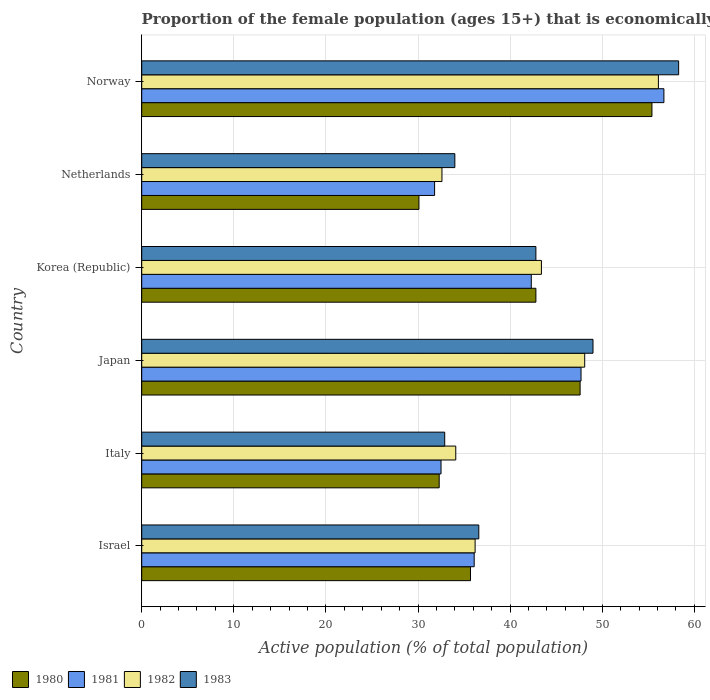Are the number of bars on each tick of the Y-axis equal?
Provide a succinct answer. Yes. How many bars are there on the 2nd tick from the top?
Keep it short and to the point. 4. What is the label of the 4th group of bars from the top?
Make the answer very short. Japan. In how many cases, is the number of bars for a given country not equal to the number of legend labels?
Offer a terse response. 0. What is the proportion of the female population that is economically active in 1983 in Norway?
Your answer should be very brief. 58.3. Across all countries, what is the maximum proportion of the female population that is economically active in 1982?
Make the answer very short. 56.1. Across all countries, what is the minimum proportion of the female population that is economically active in 1981?
Provide a short and direct response. 31.8. What is the total proportion of the female population that is economically active in 1982 in the graph?
Offer a very short reply. 250.5. What is the difference between the proportion of the female population that is economically active in 1981 in Israel and that in Norway?
Offer a terse response. -20.6. What is the difference between the proportion of the female population that is economically active in 1982 in Italy and the proportion of the female population that is economically active in 1983 in Korea (Republic)?
Offer a terse response. -8.7. What is the average proportion of the female population that is economically active in 1982 per country?
Provide a succinct answer. 41.75. What is the difference between the proportion of the female population that is economically active in 1983 and proportion of the female population that is economically active in 1982 in Norway?
Offer a very short reply. 2.2. What is the ratio of the proportion of the female population that is economically active in 1983 in Israel to that in Italy?
Provide a succinct answer. 1.11. Is the difference between the proportion of the female population that is economically active in 1983 in Italy and Korea (Republic) greater than the difference between the proportion of the female population that is economically active in 1982 in Italy and Korea (Republic)?
Offer a very short reply. No. What is the difference between the highest and the second highest proportion of the female population that is economically active in 1981?
Your answer should be compact. 9. What is the difference between the highest and the lowest proportion of the female population that is economically active in 1981?
Provide a succinct answer. 24.9. In how many countries, is the proportion of the female population that is economically active in 1980 greater than the average proportion of the female population that is economically active in 1980 taken over all countries?
Offer a terse response. 3. Is it the case that in every country, the sum of the proportion of the female population that is economically active in 1980 and proportion of the female population that is economically active in 1983 is greater than the sum of proportion of the female population that is economically active in 1982 and proportion of the female population that is economically active in 1981?
Provide a short and direct response. No. What does the 2nd bar from the top in Israel represents?
Make the answer very short. 1982. Does the graph contain any zero values?
Offer a terse response. No. Where does the legend appear in the graph?
Offer a terse response. Bottom left. How many legend labels are there?
Make the answer very short. 4. What is the title of the graph?
Your answer should be very brief. Proportion of the female population (ages 15+) that is economically active. What is the label or title of the X-axis?
Provide a short and direct response. Active population (% of total population). What is the Active population (% of total population) in 1980 in Israel?
Your answer should be compact. 35.7. What is the Active population (% of total population) of 1981 in Israel?
Provide a short and direct response. 36.1. What is the Active population (% of total population) in 1982 in Israel?
Give a very brief answer. 36.2. What is the Active population (% of total population) in 1983 in Israel?
Offer a terse response. 36.6. What is the Active population (% of total population) of 1980 in Italy?
Offer a terse response. 32.3. What is the Active population (% of total population) in 1981 in Italy?
Provide a short and direct response. 32.5. What is the Active population (% of total population) of 1982 in Italy?
Provide a succinct answer. 34.1. What is the Active population (% of total population) of 1983 in Italy?
Your response must be concise. 32.9. What is the Active population (% of total population) of 1980 in Japan?
Provide a short and direct response. 47.6. What is the Active population (% of total population) of 1981 in Japan?
Your answer should be compact. 47.7. What is the Active population (% of total population) in 1982 in Japan?
Make the answer very short. 48.1. What is the Active population (% of total population) of 1983 in Japan?
Ensure brevity in your answer.  49. What is the Active population (% of total population) of 1980 in Korea (Republic)?
Provide a short and direct response. 42.8. What is the Active population (% of total population) in 1981 in Korea (Republic)?
Provide a short and direct response. 42.3. What is the Active population (% of total population) in 1982 in Korea (Republic)?
Your response must be concise. 43.4. What is the Active population (% of total population) in 1983 in Korea (Republic)?
Offer a terse response. 42.8. What is the Active population (% of total population) of 1980 in Netherlands?
Offer a very short reply. 30.1. What is the Active population (% of total population) of 1981 in Netherlands?
Your answer should be very brief. 31.8. What is the Active population (% of total population) in 1982 in Netherlands?
Your answer should be compact. 32.6. What is the Active population (% of total population) in 1980 in Norway?
Offer a very short reply. 55.4. What is the Active population (% of total population) in 1981 in Norway?
Keep it short and to the point. 56.7. What is the Active population (% of total population) of 1982 in Norway?
Your answer should be very brief. 56.1. What is the Active population (% of total population) of 1983 in Norway?
Ensure brevity in your answer.  58.3. Across all countries, what is the maximum Active population (% of total population) of 1980?
Your response must be concise. 55.4. Across all countries, what is the maximum Active population (% of total population) of 1981?
Offer a very short reply. 56.7. Across all countries, what is the maximum Active population (% of total population) in 1982?
Your answer should be very brief. 56.1. Across all countries, what is the maximum Active population (% of total population) in 1983?
Give a very brief answer. 58.3. Across all countries, what is the minimum Active population (% of total population) in 1980?
Provide a short and direct response. 30.1. Across all countries, what is the minimum Active population (% of total population) of 1981?
Provide a short and direct response. 31.8. Across all countries, what is the minimum Active population (% of total population) of 1982?
Offer a terse response. 32.6. Across all countries, what is the minimum Active population (% of total population) in 1983?
Keep it short and to the point. 32.9. What is the total Active population (% of total population) in 1980 in the graph?
Offer a very short reply. 243.9. What is the total Active population (% of total population) of 1981 in the graph?
Offer a terse response. 247.1. What is the total Active population (% of total population) in 1982 in the graph?
Give a very brief answer. 250.5. What is the total Active population (% of total population) of 1983 in the graph?
Offer a terse response. 253.6. What is the difference between the Active population (% of total population) in 1980 in Israel and that in Italy?
Provide a succinct answer. 3.4. What is the difference between the Active population (% of total population) of 1981 in Israel and that in Italy?
Give a very brief answer. 3.6. What is the difference between the Active population (% of total population) of 1982 in Israel and that in Italy?
Provide a short and direct response. 2.1. What is the difference between the Active population (% of total population) in 1983 in Israel and that in Japan?
Offer a very short reply. -12.4. What is the difference between the Active population (% of total population) in 1981 in Israel and that in Korea (Republic)?
Provide a succinct answer. -6.2. What is the difference between the Active population (% of total population) of 1982 in Israel and that in Korea (Republic)?
Offer a very short reply. -7.2. What is the difference between the Active population (% of total population) in 1980 in Israel and that in Netherlands?
Offer a terse response. 5.6. What is the difference between the Active population (% of total population) of 1982 in Israel and that in Netherlands?
Provide a short and direct response. 3.6. What is the difference between the Active population (% of total population) in 1980 in Israel and that in Norway?
Your answer should be compact. -19.7. What is the difference between the Active population (% of total population) in 1981 in Israel and that in Norway?
Your answer should be compact. -20.6. What is the difference between the Active population (% of total population) in 1982 in Israel and that in Norway?
Your answer should be very brief. -19.9. What is the difference between the Active population (% of total population) in 1983 in Israel and that in Norway?
Your answer should be very brief. -21.7. What is the difference between the Active population (% of total population) of 1980 in Italy and that in Japan?
Provide a short and direct response. -15.3. What is the difference between the Active population (% of total population) of 1981 in Italy and that in Japan?
Your answer should be compact. -15.2. What is the difference between the Active population (% of total population) in 1982 in Italy and that in Japan?
Provide a succinct answer. -14. What is the difference between the Active population (% of total population) in 1983 in Italy and that in Japan?
Offer a terse response. -16.1. What is the difference between the Active population (% of total population) of 1980 in Italy and that in Korea (Republic)?
Keep it short and to the point. -10.5. What is the difference between the Active population (% of total population) of 1982 in Italy and that in Korea (Republic)?
Make the answer very short. -9.3. What is the difference between the Active population (% of total population) of 1983 in Italy and that in Korea (Republic)?
Give a very brief answer. -9.9. What is the difference between the Active population (% of total population) in 1980 in Italy and that in Netherlands?
Your answer should be compact. 2.2. What is the difference between the Active population (% of total population) in 1983 in Italy and that in Netherlands?
Give a very brief answer. -1.1. What is the difference between the Active population (% of total population) of 1980 in Italy and that in Norway?
Your response must be concise. -23.1. What is the difference between the Active population (% of total population) of 1981 in Italy and that in Norway?
Provide a succinct answer. -24.2. What is the difference between the Active population (% of total population) of 1982 in Italy and that in Norway?
Offer a very short reply. -22. What is the difference between the Active population (% of total population) of 1983 in Italy and that in Norway?
Offer a terse response. -25.4. What is the difference between the Active population (% of total population) in 1980 in Japan and that in Netherlands?
Offer a terse response. 17.5. What is the difference between the Active population (% of total population) in 1982 in Japan and that in Netherlands?
Give a very brief answer. 15.5. What is the difference between the Active population (% of total population) of 1981 in Japan and that in Norway?
Provide a succinct answer. -9. What is the difference between the Active population (% of total population) in 1980 in Korea (Republic) and that in Norway?
Your answer should be compact. -12.6. What is the difference between the Active population (% of total population) in 1981 in Korea (Republic) and that in Norway?
Offer a very short reply. -14.4. What is the difference between the Active population (% of total population) in 1982 in Korea (Republic) and that in Norway?
Your answer should be compact. -12.7. What is the difference between the Active population (% of total population) of 1983 in Korea (Republic) and that in Norway?
Your answer should be compact. -15.5. What is the difference between the Active population (% of total population) in 1980 in Netherlands and that in Norway?
Make the answer very short. -25.3. What is the difference between the Active population (% of total population) of 1981 in Netherlands and that in Norway?
Offer a very short reply. -24.9. What is the difference between the Active population (% of total population) of 1982 in Netherlands and that in Norway?
Offer a terse response. -23.5. What is the difference between the Active population (% of total population) in 1983 in Netherlands and that in Norway?
Offer a very short reply. -24.3. What is the difference between the Active population (% of total population) of 1980 in Israel and the Active population (% of total population) of 1981 in Italy?
Provide a succinct answer. 3.2. What is the difference between the Active population (% of total population) in 1980 in Israel and the Active population (% of total population) in 1982 in Italy?
Provide a succinct answer. 1.6. What is the difference between the Active population (% of total population) of 1982 in Israel and the Active population (% of total population) of 1983 in Italy?
Make the answer very short. 3.3. What is the difference between the Active population (% of total population) of 1980 in Israel and the Active population (% of total population) of 1982 in Japan?
Your answer should be very brief. -12.4. What is the difference between the Active population (% of total population) in 1980 in Israel and the Active population (% of total population) in 1983 in Japan?
Provide a succinct answer. -13.3. What is the difference between the Active population (% of total population) of 1981 in Israel and the Active population (% of total population) of 1983 in Japan?
Give a very brief answer. -12.9. What is the difference between the Active population (% of total population) in 1982 in Israel and the Active population (% of total population) in 1983 in Japan?
Make the answer very short. -12.8. What is the difference between the Active population (% of total population) in 1980 in Israel and the Active population (% of total population) in 1983 in Korea (Republic)?
Your answer should be very brief. -7.1. What is the difference between the Active population (% of total population) in 1980 in Israel and the Active population (% of total population) in 1981 in Netherlands?
Your answer should be compact. 3.9. What is the difference between the Active population (% of total population) in 1980 in Israel and the Active population (% of total population) in 1983 in Netherlands?
Your answer should be very brief. 1.7. What is the difference between the Active population (% of total population) of 1981 in Israel and the Active population (% of total population) of 1982 in Netherlands?
Offer a terse response. 3.5. What is the difference between the Active population (% of total population) in 1982 in Israel and the Active population (% of total population) in 1983 in Netherlands?
Your answer should be compact. 2.2. What is the difference between the Active population (% of total population) of 1980 in Israel and the Active population (% of total population) of 1982 in Norway?
Keep it short and to the point. -20.4. What is the difference between the Active population (% of total population) in 1980 in Israel and the Active population (% of total population) in 1983 in Norway?
Your answer should be compact. -22.6. What is the difference between the Active population (% of total population) in 1981 in Israel and the Active population (% of total population) in 1982 in Norway?
Your answer should be compact. -20. What is the difference between the Active population (% of total population) in 1981 in Israel and the Active population (% of total population) in 1983 in Norway?
Keep it short and to the point. -22.2. What is the difference between the Active population (% of total population) in 1982 in Israel and the Active population (% of total population) in 1983 in Norway?
Make the answer very short. -22.1. What is the difference between the Active population (% of total population) of 1980 in Italy and the Active population (% of total population) of 1981 in Japan?
Offer a terse response. -15.4. What is the difference between the Active population (% of total population) of 1980 in Italy and the Active population (% of total population) of 1982 in Japan?
Ensure brevity in your answer.  -15.8. What is the difference between the Active population (% of total population) in 1980 in Italy and the Active population (% of total population) in 1983 in Japan?
Your response must be concise. -16.7. What is the difference between the Active population (% of total population) in 1981 in Italy and the Active population (% of total population) in 1982 in Japan?
Offer a terse response. -15.6. What is the difference between the Active population (% of total population) of 1981 in Italy and the Active population (% of total population) of 1983 in Japan?
Keep it short and to the point. -16.5. What is the difference between the Active population (% of total population) of 1982 in Italy and the Active population (% of total population) of 1983 in Japan?
Offer a very short reply. -14.9. What is the difference between the Active population (% of total population) in 1980 in Italy and the Active population (% of total population) in 1982 in Korea (Republic)?
Your answer should be compact. -11.1. What is the difference between the Active population (% of total population) in 1980 in Italy and the Active population (% of total population) in 1983 in Korea (Republic)?
Offer a very short reply. -10.5. What is the difference between the Active population (% of total population) in 1982 in Italy and the Active population (% of total population) in 1983 in Korea (Republic)?
Provide a succinct answer. -8.7. What is the difference between the Active population (% of total population) in 1980 in Italy and the Active population (% of total population) in 1983 in Netherlands?
Provide a short and direct response. -1.7. What is the difference between the Active population (% of total population) in 1981 in Italy and the Active population (% of total population) in 1983 in Netherlands?
Your response must be concise. -1.5. What is the difference between the Active population (% of total population) of 1980 in Italy and the Active population (% of total population) of 1981 in Norway?
Make the answer very short. -24.4. What is the difference between the Active population (% of total population) in 1980 in Italy and the Active population (% of total population) in 1982 in Norway?
Make the answer very short. -23.8. What is the difference between the Active population (% of total population) of 1981 in Italy and the Active population (% of total population) of 1982 in Norway?
Your response must be concise. -23.6. What is the difference between the Active population (% of total population) in 1981 in Italy and the Active population (% of total population) in 1983 in Norway?
Offer a terse response. -25.8. What is the difference between the Active population (% of total population) of 1982 in Italy and the Active population (% of total population) of 1983 in Norway?
Give a very brief answer. -24.2. What is the difference between the Active population (% of total population) of 1980 in Japan and the Active population (% of total population) of 1982 in Korea (Republic)?
Provide a short and direct response. 4.2. What is the difference between the Active population (% of total population) of 1980 in Japan and the Active population (% of total population) of 1983 in Korea (Republic)?
Offer a terse response. 4.8. What is the difference between the Active population (% of total population) in 1981 in Japan and the Active population (% of total population) in 1983 in Korea (Republic)?
Your response must be concise. 4.9. What is the difference between the Active population (% of total population) in 1982 in Japan and the Active population (% of total population) in 1983 in Korea (Republic)?
Your answer should be compact. 5.3. What is the difference between the Active population (% of total population) of 1980 in Japan and the Active population (% of total population) of 1982 in Netherlands?
Your answer should be compact. 15. What is the difference between the Active population (% of total population) in 1981 in Japan and the Active population (% of total population) in 1983 in Netherlands?
Your answer should be very brief. 13.7. What is the difference between the Active population (% of total population) in 1982 in Japan and the Active population (% of total population) in 1983 in Netherlands?
Your answer should be very brief. 14.1. What is the difference between the Active population (% of total population) in 1980 in Japan and the Active population (% of total population) in 1982 in Norway?
Your answer should be very brief. -8.5. What is the difference between the Active population (% of total population) of 1980 in Japan and the Active population (% of total population) of 1983 in Norway?
Your response must be concise. -10.7. What is the difference between the Active population (% of total population) of 1981 in Japan and the Active population (% of total population) of 1983 in Norway?
Offer a terse response. -10.6. What is the difference between the Active population (% of total population) of 1982 in Japan and the Active population (% of total population) of 1983 in Norway?
Keep it short and to the point. -10.2. What is the difference between the Active population (% of total population) in 1980 in Korea (Republic) and the Active population (% of total population) in 1981 in Netherlands?
Provide a succinct answer. 11. What is the difference between the Active population (% of total population) in 1980 in Korea (Republic) and the Active population (% of total population) in 1983 in Netherlands?
Your response must be concise. 8.8. What is the difference between the Active population (% of total population) in 1981 in Korea (Republic) and the Active population (% of total population) in 1982 in Netherlands?
Provide a succinct answer. 9.7. What is the difference between the Active population (% of total population) of 1981 in Korea (Republic) and the Active population (% of total population) of 1983 in Netherlands?
Provide a succinct answer. 8.3. What is the difference between the Active population (% of total population) in 1982 in Korea (Republic) and the Active population (% of total population) in 1983 in Netherlands?
Give a very brief answer. 9.4. What is the difference between the Active population (% of total population) of 1980 in Korea (Republic) and the Active population (% of total population) of 1983 in Norway?
Ensure brevity in your answer.  -15.5. What is the difference between the Active population (% of total population) of 1981 in Korea (Republic) and the Active population (% of total population) of 1983 in Norway?
Provide a short and direct response. -16. What is the difference between the Active population (% of total population) in 1982 in Korea (Republic) and the Active population (% of total population) in 1983 in Norway?
Ensure brevity in your answer.  -14.9. What is the difference between the Active population (% of total population) in 1980 in Netherlands and the Active population (% of total population) in 1981 in Norway?
Provide a short and direct response. -26.6. What is the difference between the Active population (% of total population) in 1980 in Netherlands and the Active population (% of total population) in 1983 in Norway?
Give a very brief answer. -28.2. What is the difference between the Active population (% of total population) of 1981 in Netherlands and the Active population (% of total population) of 1982 in Norway?
Keep it short and to the point. -24.3. What is the difference between the Active population (% of total population) of 1981 in Netherlands and the Active population (% of total population) of 1983 in Norway?
Your response must be concise. -26.5. What is the difference between the Active population (% of total population) in 1982 in Netherlands and the Active population (% of total population) in 1983 in Norway?
Ensure brevity in your answer.  -25.7. What is the average Active population (% of total population) in 1980 per country?
Offer a very short reply. 40.65. What is the average Active population (% of total population) in 1981 per country?
Ensure brevity in your answer.  41.18. What is the average Active population (% of total population) in 1982 per country?
Your answer should be compact. 41.75. What is the average Active population (% of total population) in 1983 per country?
Offer a very short reply. 42.27. What is the difference between the Active population (% of total population) of 1980 and Active population (% of total population) of 1981 in Israel?
Provide a succinct answer. -0.4. What is the difference between the Active population (% of total population) of 1980 and Active population (% of total population) of 1983 in Israel?
Keep it short and to the point. -0.9. What is the difference between the Active population (% of total population) in 1981 and Active population (% of total population) in 1982 in Israel?
Provide a succinct answer. -0.1. What is the difference between the Active population (% of total population) of 1981 and Active population (% of total population) of 1983 in Israel?
Offer a very short reply. -0.5. What is the difference between the Active population (% of total population) in 1982 and Active population (% of total population) in 1983 in Israel?
Make the answer very short. -0.4. What is the difference between the Active population (% of total population) in 1980 and Active population (% of total population) in 1982 in Italy?
Make the answer very short. -1.8. What is the difference between the Active population (% of total population) in 1981 and Active population (% of total population) in 1983 in Italy?
Offer a very short reply. -0.4. What is the difference between the Active population (% of total population) of 1980 and Active population (% of total population) of 1981 in Japan?
Offer a very short reply. -0.1. What is the difference between the Active population (% of total population) of 1981 and Active population (% of total population) of 1982 in Japan?
Ensure brevity in your answer.  -0.4. What is the difference between the Active population (% of total population) in 1980 and Active population (% of total population) in 1981 in Korea (Republic)?
Your answer should be very brief. 0.5. What is the difference between the Active population (% of total population) of 1981 and Active population (% of total population) of 1983 in Korea (Republic)?
Give a very brief answer. -0.5. What is the difference between the Active population (% of total population) of 1982 and Active population (% of total population) of 1983 in Korea (Republic)?
Provide a succinct answer. 0.6. What is the difference between the Active population (% of total population) of 1980 and Active population (% of total population) of 1982 in Netherlands?
Ensure brevity in your answer.  -2.5. What is the difference between the Active population (% of total population) of 1980 and Active population (% of total population) of 1983 in Netherlands?
Provide a succinct answer. -3.9. What is the difference between the Active population (% of total population) of 1981 and Active population (% of total population) of 1982 in Netherlands?
Your answer should be compact. -0.8. What is the difference between the Active population (% of total population) of 1981 and Active population (% of total population) of 1983 in Netherlands?
Your answer should be very brief. -2.2. What is the difference between the Active population (% of total population) in 1982 and Active population (% of total population) in 1983 in Netherlands?
Offer a very short reply. -1.4. What is the difference between the Active population (% of total population) in 1980 and Active population (% of total population) in 1981 in Norway?
Give a very brief answer. -1.3. What is the difference between the Active population (% of total population) of 1980 and Active population (% of total population) of 1983 in Norway?
Provide a short and direct response. -2.9. What is the difference between the Active population (% of total population) in 1981 and Active population (% of total population) in 1983 in Norway?
Provide a succinct answer. -1.6. What is the ratio of the Active population (% of total population) in 1980 in Israel to that in Italy?
Your answer should be very brief. 1.11. What is the ratio of the Active population (% of total population) in 1981 in Israel to that in Italy?
Offer a very short reply. 1.11. What is the ratio of the Active population (% of total population) of 1982 in Israel to that in Italy?
Make the answer very short. 1.06. What is the ratio of the Active population (% of total population) in 1983 in Israel to that in Italy?
Your answer should be compact. 1.11. What is the ratio of the Active population (% of total population) in 1981 in Israel to that in Japan?
Keep it short and to the point. 0.76. What is the ratio of the Active population (% of total population) in 1982 in Israel to that in Japan?
Provide a succinct answer. 0.75. What is the ratio of the Active population (% of total population) in 1983 in Israel to that in Japan?
Offer a terse response. 0.75. What is the ratio of the Active population (% of total population) of 1980 in Israel to that in Korea (Republic)?
Ensure brevity in your answer.  0.83. What is the ratio of the Active population (% of total population) in 1981 in Israel to that in Korea (Republic)?
Your answer should be compact. 0.85. What is the ratio of the Active population (% of total population) in 1982 in Israel to that in Korea (Republic)?
Offer a terse response. 0.83. What is the ratio of the Active population (% of total population) in 1983 in Israel to that in Korea (Republic)?
Ensure brevity in your answer.  0.86. What is the ratio of the Active population (% of total population) in 1980 in Israel to that in Netherlands?
Give a very brief answer. 1.19. What is the ratio of the Active population (% of total population) of 1981 in Israel to that in Netherlands?
Provide a short and direct response. 1.14. What is the ratio of the Active population (% of total population) in 1982 in Israel to that in Netherlands?
Ensure brevity in your answer.  1.11. What is the ratio of the Active population (% of total population) in 1983 in Israel to that in Netherlands?
Your answer should be compact. 1.08. What is the ratio of the Active population (% of total population) of 1980 in Israel to that in Norway?
Offer a very short reply. 0.64. What is the ratio of the Active population (% of total population) of 1981 in Israel to that in Norway?
Your answer should be compact. 0.64. What is the ratio of the Active population (% of total population) in 1982 in Israel to that in Norway?
Your answer should be compact. 0.65. What is the ratio of the Active population (% of total population) in 1983 in Israel to that in Norway?
Keep it short and to the point. 0.63. What is the ratio of the Active population (% of total population) in 1980 in Italy to that in Japan?
Your response must be concise. 0.68. What is the ratio of the Active population (% of total population) of 1981 in Italy to that in Japan?
Offer a terse response. 0.68. What is the ratio of the Active population (% of total population) of 1982 in Italy to that in Japan?
Provide a short and direct response. 0.71. What is the ratio of the Active population (% of total population) of 1983 in Italy to that in Japan?
Provide a succinct answer. 0.67. What is the ratio of the Active population (% of total population) of 1980 in Italy to that in Korea (Republic)?
Your answer should be compact. 0.75. What is the ratio of the Active population (% of total population) of 1981 in Italy to that in Korea (Republic)?
Your response must be concise. 0.77. What is the ratio of the Active population (% of total population) in 1982 in Italy to that in Korea (Republic)?
Provide a short and direct response. 0.79. What is the ratio of the Active population (% of total population) in 1983 in Italy to that in Korea (Republic)?
Make the answer very short. 0.77. What is the ratio of the Active population (% of total population) of 1980 in Italy to that in Netherlands?
Your answer should be compact. 1.07. What is the ratio of the Active population (% of total population) of 1982 in Italy to that in Netherlands?
Your answer should be very brief. 1.05. What is the ratio of the Active population (% of total population) in 1983 in Italy to that in Netherlands?
Your answer should be compact. 0.97. What is the ratio of the Active population (% of total population) of 1980 in Italy to that in Norway?
Your answer should be compact. 0.58. What is the ratio of the Active population (% of total population) of 1981 in Italy to that in Norway?
Your answer should be very brief. 0.57. What is the ratio of the Active population (% of total population) of 1982 in Italy to that in Norway?
Your answer should be compact. 0.61. What is the ratio of the Active population (% of total population) in 1983 in Italy to that in Norway?
Your answer should be very brief. 0.56. What is the ratio of the Active population (% of total population) in 1980 in Japan to that in Korea (Republic)?
Offer a very short reply. 1.11. What is the ratio of the Active population (% of total population) in 1981 in Japan to that in Korea (Republic)?
Make the answer very short. 1.13. What is the ratio of the Active population (% of total population) in 1982 in Japan to that in Korea (Republic)?
Offer a terse response. 1.11. What is the ratio of the Active population (% of total population) in 1983 in Japan to that in Korea (Republic)?
Provide a succinct answer. 1.14. What is the ratio of the Active population (% of total population) in 1980 in Japan to that in Netherlands?
Make the answer very short. 1.58. What is the ratio of the Active population (% of total population) in 1981 in Japan to that in Netherlands?
Your answer should be very brief. 1.5. What is the ratio of the Active population (% of total population) of 1982 in Japan to that in Netherlands?
Ensure brevity in your answer.  1.48. What is the ratio of the Active population (% of total population) of 1983 in Japan to that in Netherlands?
Make the answer very short. 1.44. What is the ratio of the Active population (% of total population) in 1980 in Japan to that in Norway?
Provide a succinct answer. 0.86. What is the ratio of the Active population (% of total population) of 1981 in Japan to that in Norway?
Keep it short and to the point. 0.84. What is the ratio of the Active population (% of total population) in 1982 in Japan to that in Norway?
Offer a terse response. 0.86. What is the ratio of the Active population (% of total population) of 1983 in Japan to that in Norway?
Provide a short and direct response. 0.84. What is the ratio of the Active population (% of total population) in 1980 in Korea (Republic) to that in Netherlands?
Provide a short and direct response. 1.42. What is the ratio of the Active population (% of total population) of 1981 in Korea (Republic) to that in Netherlands?
Keep it short and to the point. 1.33. What is the ratio of the Active population (% of total population) in 1982 in Korea (Republic) to that in Netherlands?
Your answer should be compact. 1.33. What is the ratio of the Active population (% of total population) in 1983 in Korea (Republic) to that in Netherlands?
Offer a very short reply. 1.26. What is the ratio of the Active population (% of total population) in 1980 in Korea (Republic) to that in Norway?
Provide a short and direct response. 0.77. What is the ratio of the Active population (% of total population) of 1981 in Korea (Republic) to that in Norway?
Keep it short and to the point. 0.75. What is the ratio of the Active population (% of total population) of 1982 in Korea (Republic) to that in Norway?
Make the answer very short. 0.77. What is the ratio of the Active population (% of total population) in 1983 in Korea (Republic) to that in Norway?
Offer a very short reply. 0.73. What is the ratio of the Active population (% of total population) in 1980 in Netherlands to that in Norway?
Your response must be concise. 0.54. What is the ratio of the Active population (% of total population) of 1981 in Netherlands to that in Norway?
Offer a terse response. 0.56. What is the ratio of the Active population (% of total population) of 1982 in Netherlands to that in Norway?
Your response must be concise. 0.58. What is the ratio of the Active population (% of total population) of 1983 in Netherlands to that in Norway?
Ensure brevity in your answer.  0.58. What is the difference between the highest and the second highest Active population (% of total population) in 1980?
Make the answer very short. 7.8. What is the difference between the highest and the second highest Active population (% of total population) in 1981?
Offer a very short reply. 9. What is the difference between the highest and the lowest Active population (% of total population) of 1980?
Your response must be concise. 25.3. What is the difference between the highest and the lowest Active population (% of total population) of 1981?
Offer a very short reply. 24.9. What is the difference between the highest and the lowest Active population (% of total population) in 1982?
Offer a very short reply. 23.5. What is the difference between the highest and the lowest Active population (% of total population) of 1983?
Your answer should be very brief. 25.4. 